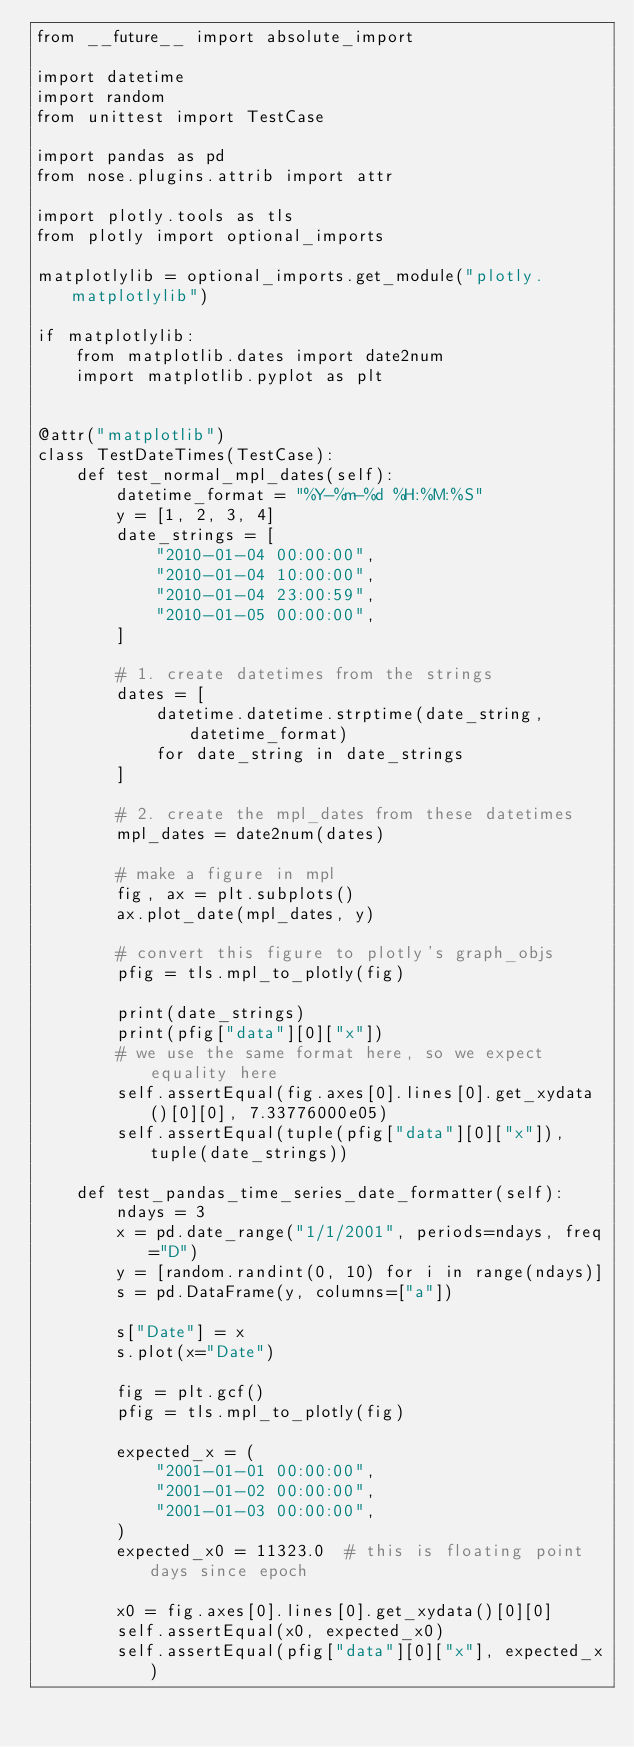<code> <loc_0><loc_0><loc_500><loc_500><_Python_>from __future__ import absolute_import

import datetime
import random
from unittest import TestCase

import pandas as pd
from nose.plugins.attrib import attr

import plotly.tools as tls
from plotly import optional_imports

matplotlylib = optional_imports.get_module("plotly.matplotlylib")

if matplotlylib:
    from matplotlib.dates import date2num
    import matplotlib.pyplot as plt


@attr("matplotlib")
class TestDateTimes(TestCase):
    def test_normal_mpl_dates(self):
        datetime_format = "%Y-%m-%d %H:%M:%S"
        y = [1, 2, 3, 4]
        date_strings = [
            "2010-01-04 00:00:00",
            "2010-01-04 10:00:00",
            "2010-01-04 23:00:59",
            "2010-01-05 00:00:00",
        ]

        # 1. create datetimes from the strings
        dates = [
            datetime.datetime.strptime(date_string, datetime_format)
            for date_string in date_strings
        ]

        # 2. create the mpl_dates from these datetimes
        mpl_dates = date2num(dates)

        # make a figure in mpl
        fig, ax = plt.subplots()
        ax.plot_date(mpl_dates, y)

        # convert this figure to plotly's graph_objs
        pfig = tls.mpl_to_plotly(fig)

        print(date_strings)
        print(pfig["data"][0]["x"])
        # we use the same format here, so we expect equality here
        self.assertEqual(fig.axes[0].lines[0].get_xydata()[0][0], 7.33776000e05)
        self.assertEqual(tuple(pfig["data"][0]["x"]), tuple(date_strings))

    def test_pandas_time_series_date_formatter(self):
        ndays = 3
        x = pd.date_range("1/1/2001", periods=ndays, freq="D")
        y = [random.randint(0, 10) for i in range(ndays)]
        s = pd.DataFrame(y, columns=["a"])

        s["Date"] = x
        s.plot(x="Date")

        fig = plt.gcf()
        pfig = tls.mpl_to_plotly(fig)

        expected_x = (
            "2001-01-01 00:00:00",
            "2001-01-02 00:00:00",
            "2001-01-03 00:00:00",
        )
        expected_x0 = 11323.0  # this is floating point days since epoch

        x0 = fig.axes[0].lines[0].get_xydata()[0][0]
        self.assertEqual(x0, expected_x0)
        self.assertEqual(pfig["data"][0]["x"], expected_x)
</code> 